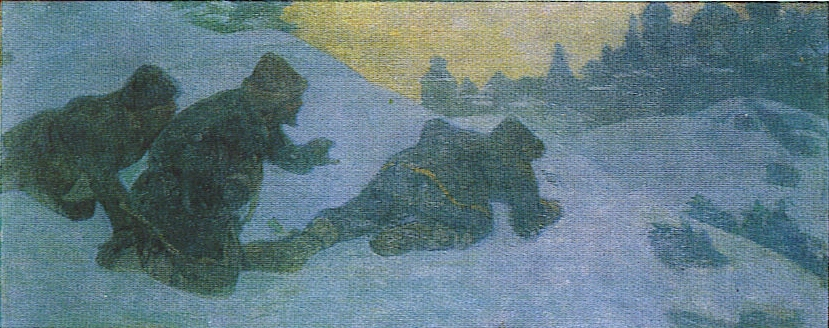Explain the visual content of the image in great detail. The image portrays a group of three figures making their way through a snowy, wintry landscape. The scene is painted in an impressionist style, characterized by loose and expressive brushstrokes that capture the atmosphere rather than the precise details. Dominated by cool tones primarily in blues and greens, the composition is balanced by a warm yellow hue illuminating the sky in the background, suggesting dawn or dusk. The figures, heavily dressed in thick coats and pointed hats, are crouching and appear to be strategizing or on a mission, possibly hinting at a historical or cultural context. The attire suggests a Russian influence, possibly indicating a scene set in rural Russia during winter. The surrounding environment includes what appears to be distant treetops and architectural structures, hinting at a village or settlement. The impressionistic technique and the everyday subject matter suggest that this painting could be classified as a genre painting, capturing a moment of human experience in harsh winter conditions. 